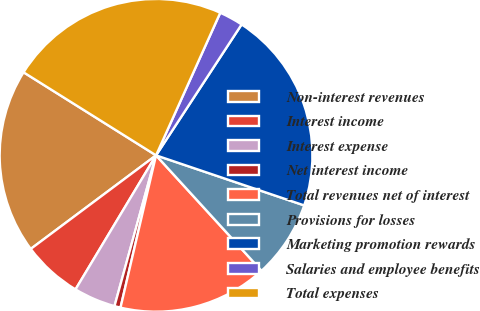<chart> <loc_0><loc_0><loc_500><loc_500><pie_chart><fcel>Non-interest revenues<fcel>Interest income<fcel>Interest expense<fcel>Net interest income<fcel>Total revenues net of interest<fcel>Provisions for losses<fcel>Marketing promotion rewards<fcel>Salaries and employee benefits<fcel>Total expenses<nl><fcel>19.12%<fcel>6.18%<fcel>4.33%<fcel>0.63%<fcel>15.43%<fcel>8.03%<fcel>20.97%<fcel>2.48%<fcel>22.82%<nl></chart> 